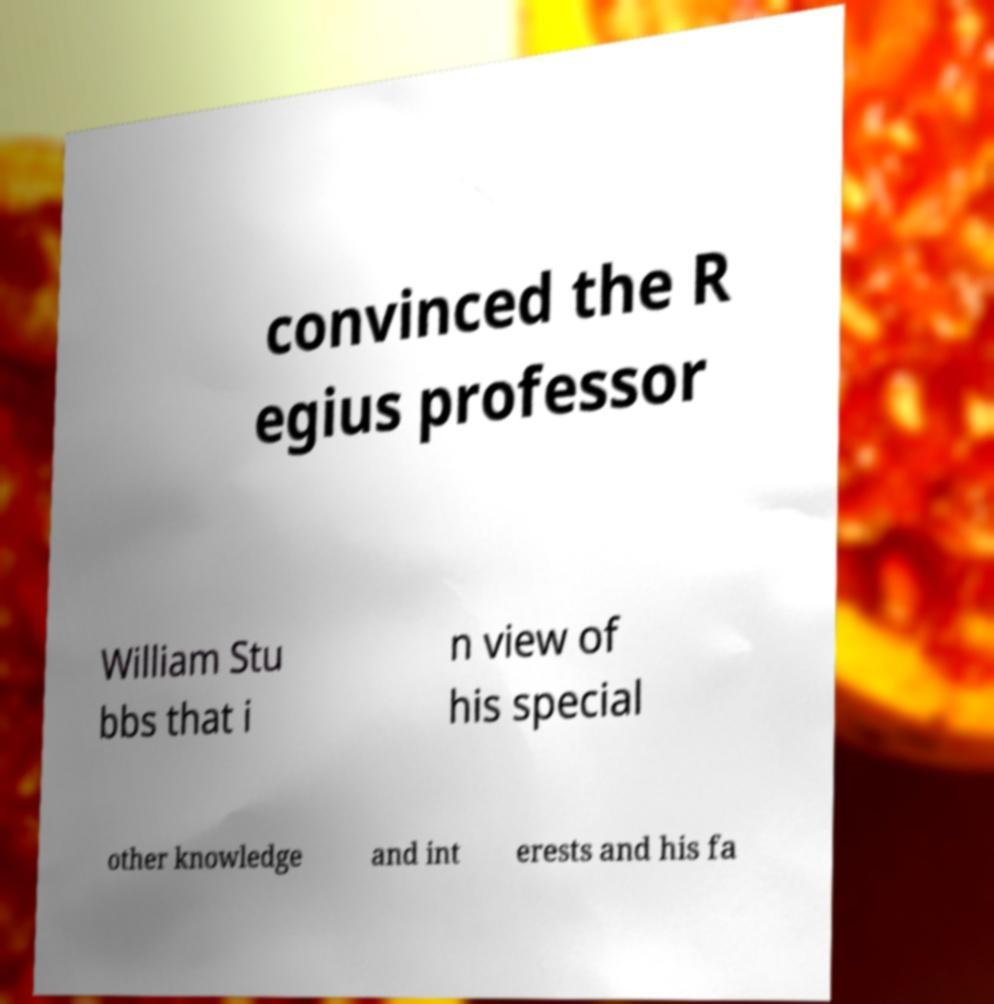What messages or text are displayed in this image? I need them in a readable, typed format. convinced the R egius professor William Stu bbs that i n view of his special other knowledge and int erests and his fa 